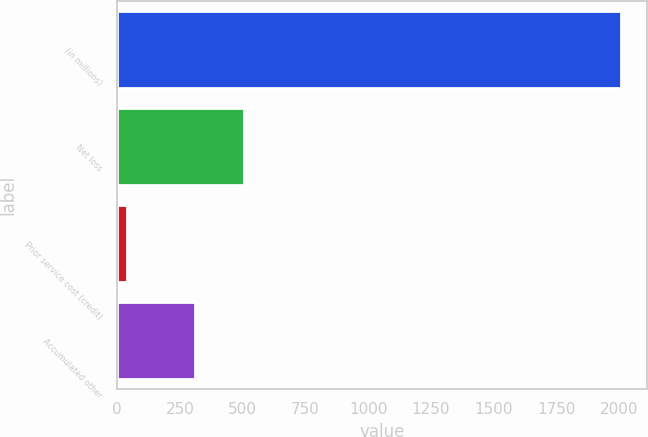<chart> <loc_0><loc_0><loc_500><loc_500><bar_chart><fcel>(in millions)<fcel>Net loss<fcel>Prior service cost (credit)<fcel>Accumulated other<nl><fcel>2008<fcel>505.8<fcel>40<fcel>309<nl></chart> 